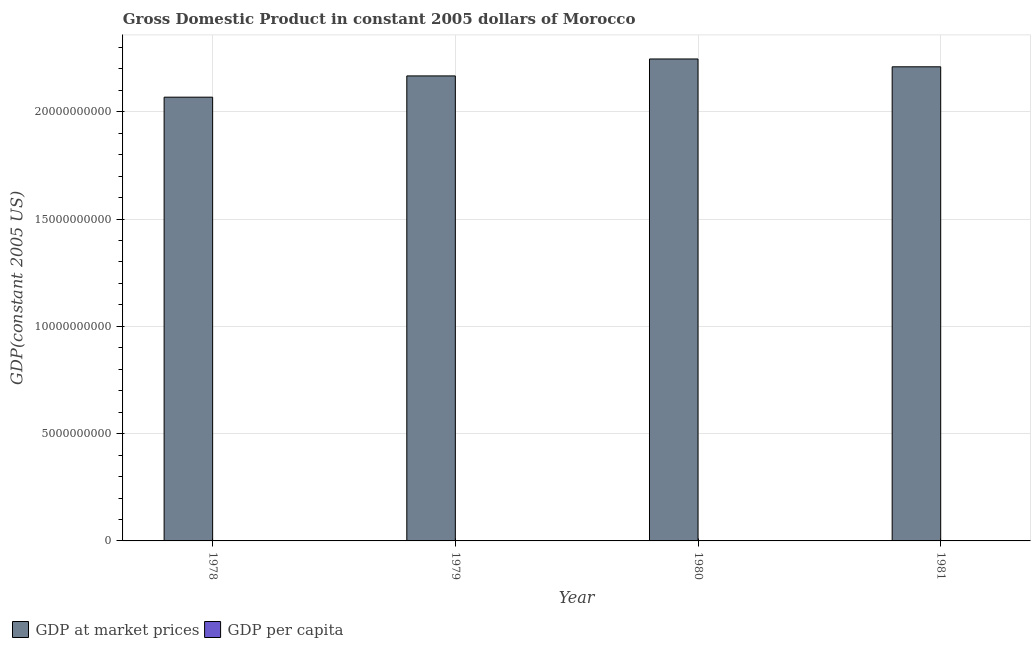How many different coloured bars are there?
Your answer should be compact. 2. What is the label of the 4th group of bars from the left?
Provide a succinct answer. 1981. What is the gdp at market prices in 1978?
Give a very brief answer. 2.07e+1. Across all years, what is the maximum gdp at market prices?
Offer a very short reply. 2.25e+1. Across all years, what is the minimum gdp at market prices?
Provide a succinct answer. 2.07e+1. In which year was the gdp at market prices minimum?
Give a very brief answer. 1978. What is the total gdp per capita in the graph?
Your response must be concise. 4349.45. What is the difference between the gdp per capita in 1978 and that in 1979?
Your response must be concise. -24.17. What is the difference between the gdp per capita in 1979 and the gdp at market prices in 1980?
Your answer should be very brief. -12.37. What is the average gdp at market prices per year?
Your answer should be very brief. 2.17e+1. In how many years, is the gdp per capita greater than 1000000000 US$?
Provide a short and direct response. 0. What is the ratio of the gdp at market prices in 1978 to that in 1980?
Your answer should be very brief. 0.92. Is the gdp at market prices in 1978 less than that in 1980?
Ensure brevity in your answer.  Yes. Is the difference between the gdp per capita in 1978 and 1980 greater than the difference between the gdp at market prices in 1978 and 1980?
Provide a short and direct response. No. What is the difference between the highest and the second highest gdp at market prices?
Give a very brief answer. 3.65e+08. What is the difference between the highest and the lowest gdp per capita?
Make the answer very short. 44.57. Is the sum of the gdp at market prices in 1979 and 1981 greater than the maximum gdp per capita across all years?
Offer a very short reply. Yes. What does the 2nd bar from the left in 1980 represents?
Keep it short and to the point. GDP per capita. What does the 1st bar from the right in 1978 represents?
Offer a very short reply. GDP per capita. Are all the bars in the graph horizontal?
Give a very brief answer. No. How many years are there in the graph?
Your answer should be very brief. 4. What is the difference between two consecutive major ticks on the Y-axis?
Provide a succinct answer. 5.00e+09. Does the graph contain grids?
Offer a very short reply. Yes. Where does the legend appear in the graph?
Give a very brief answer. Bottom left. How many legend labels are there?
Keep it short and to the point. 2. What is the title of the graph?
Offer a terse response. Gross Domestic Product in constant 2005 dollars of Morocco. What is the label or title of the Y-axis?
Provide a succinct answer. GDP(constant 2005 US). What is the GDP(constant 2005 US) in GDP at market prices in 1978?
Offer a very short reply. 2.07e+1. What is the GDP(constant 2005 US) in GDP per capita in 1978?
Give a very brief answer. 1074.2. What is the GDP(constant 2005 US) in GDP at market prices in 1979?
Provide a succinct answer. 2.17e+1. What is the GDP(constant 2005 US) in GDP per capita in 1979?
Give a very brief answer. 1098.36. What is the GDP(constant 2005 US) of GDP at market prices in 1980?
Give a very brief answer. 2.25e+1. What is the GDP(constant 2005 US) in GDP per capita in 1980?
Make the answer very short. 1110.73. What is the GDP(constant 2005 US) in GDP at market prices in 1981?
Provide a succinct answer. 2.21e+1. What is the GDP(constant 2005 US) of GDP per capita in 1981?
Provide a short and direct response. 1066.16. Across all years, what is the maximum GDP(constant 2005 US) in GDP at market prices?
Offer a terse response. 2.25e+1. Across all years, what is the maximum GDP(constant 2005 US) in GDP per capita?
Your response must be concise. 1110.73. Across all years, what is the minimum GDP(constant 2005 US) of GDP at market prices?
Provide a succinct answer. 2.07e+1. Across all years, what is the minimum GDP(constant 2005 US) of GDP per capita?
Keep it short and to the point. 1066.16. What is the total GDP(constant 2005 US) of GDP at market prices in the graph?
Your answer should be compact. 8.69e+1. What is the total GDP(constant 2005 US) in GDP per capita in the graph?
Keep it short and to the point. 4349.45. What is the difference between the GDP(constant 2005 US) in GDP at market prices in 1978 and that in 1979?
Your response must be concise. -9.91e+08. What is the difference between the GDP(constant 2005 US) of GDP per capita in 1978 and that in 1979?
Give a very brief answer. -24.17. What is the difference between the GDP(constant 2005 US) of GDP at market prices in 1978 and that in 1980?
Your answer should be compact. -1.78e+09. What is the difference between the GDP(constant 2005 US) in GDP per capita in 1978 and that in 1980?
Make the answer very short. -36.53. What is the difference between the GDP(constant 2005 US) in GDP at market prices in 1978 and that in 1981?
Provide a succinct answer. -1.42e+09. What is the difference between the GDP(constant 2005 US) of GDP per capita in 1978 and that in 1981?
Provide a short and direct response. 8.03. What is the difference between the GDP(constant 2005 US) in GDP at market prices in 1979 and that in 1980?
Your answer should be very brief. -7.89e+08. What is the difference between the GDP(constant 2005 US) of GDP per capita in 1979 and that in 1980?
Ensure brevity in your answer.  -12.37. What is the difference between the GDP(constant 2005 US) of GDP at market prices in 1979 and that in 1981?
Your answer should be very brief. -4.24e+08. What is the difference between the GDP(constant 2005 US) in GDP per capita in 1979 and that in 1981?
Keep it short and to the point. 32.2. What is the difference between the GDP(constant 2005 US) in GDP at market prices in 1980 and that in 1981?
Your answer should be compact. 3.65e+08. What is the difference between the GDP(constant 2005 US) of GDP per capita in 1980 and that in 1981?
Your answer should be very brief. 44.57. What is the difference between the GDP(constant 2005 US) in GDP at market prices in 1978 and the GDP(constant 2005 US) in GDP per capita in 1979?
Ensure brevity in your answer.  2.07e+1. What is the difference between the GDP(constant 2005 US) in GDP at market prices in 1978 and the GDP(constant 2005 US) in GDP per capita in 1980?
Offer a terse response. 2.07e+1. What is the difference between the GDP(constant 2005 US) in GDP at market prices in 1978 and the GDP(constant 2005 US) in GDP per capita in 1981?
Ensure brevity in your answer.  2.07e+1. What is the difference between the GDP(constant 2005 US) in GDP at market prices in 1979 and the GDP(constant 2005 US) in GDP per capita in 1980?
Ensure brevity in your answer.  2.17e+1. What is the difference between the GDP(constant 2005 US) of GDP at market prices in 1979 and the GDP(constant 2005 US) of GDP per capita in 1981?
Offer a terse response. 2.17e+1. What is the difference between the GDP(constant 2005 US) in GDP at market prices in 1980 and the GDP(constant 2005 US) in GDP per capita in 1981?
Your response must be concise. 2.25e+1. What is the average GDP(constant 2005 US) of GDP at market prices per year?
Your answer should be compact. 2.17e+1. What is the average GDP(constant 2005 US) in GDP per capita per year?
Ensure brevity in your answer.  1087.36. In the year 1978, what is the difference between the GDP(constant 2005 US) in GDP at market prices and GDP(constant 2005 US) in GDP per capita?
Make the answer very short. 2.07e+1. In the year 1979, what is the difference between the GDP(constant 2005 US) of GDP at market prices and GDP(constant 2005 US) of GDP per capita?
Ensure brevity in your answer.  2.17e+1. In the year 1980, what is the difference between the GDP(constant 2005 US) in GDP at market prices and GDP(constant 2005 US) in GDP per capita?
Keep it short and to the point. 2.25e+1. In the year 1981, what is the difference between the GDP(constant 2005 US) in GDP at market prices and GDP(constant 2005 US) in GDP per capita?
Your answer should be very brief. 2.21e+1. What is the ratio of the GDP(constant 2005 US) of GDP at market prices in 1978 to that in 1979?
Your answer should be compact. 0.95. What is the ratio of the GDP(constant 2005 US) of GDP per capita in 1978 to that in 1979?
Provide a succinct answer. 0.98. What is the ratio of the GDP(constant 2005 US) of GDP at market prices in 1978 to that in 1980?
Offer a very short reply. 0.92. What is the ratio of the GDP(constant 2005 US) of GDP per capita in 1978 to that in 1980?
Ensure brevity in your answer.  0.97. What is the ratio of the GDP(constant 2005 US) in GDP at market prices in 1978 to that in 1981?
Give a very brief answer. 0.94. What is the ratio of the GDP(constant 2005 US) of GDP per capita in 1978 to that in 1981?
Your response must be concise. 1.01. What is the ratio of the GDP(constant 2005 US) of GDP at market prices in 1979 to that in 1980?
Ensure brevity in your answer.  0.96. What is the ratio of the GDP(constant 2005 US) of GDP per capita in 1979 to that in 1980?
Your response must be concise. 0.99. What is the ratio of the GDP(constant 2005 US) of GDP at market prices in 1979 to that in 1981?
Offer a very short reply. 0.98. What is the ratio of the GDP(constant 2005 US) in GDP per capita in 1979 to that in 1981?
Your answer should be very brief. 1.03. What is the ratio of the GDP(constant 2005 US) of GDP at market prices in 1980 to that in 1981?
Offer a terse response. 1.02. What is the ratio of the GDP(constant 2005 US) of GDP per capita in 1980 to that in 1981?
Ensure brevity in your answer.  1.04. What is the difference between the highest and the second highest GDP(constant 2005 US) of GDP at market prices?
Keep it short and to the point. 3.65e+08. What is the difference between the highest and the second highest GDP(constant 2005 US) of GDP per capita?
Give a very brief answer. 12.37. What is the difference between the highest and the lowest GDP(constant 2005 US) of GDP at market prices?
Offer a terse response. 1.78e+09. What is the difference between the highest and the lowest GDP(constant 2005 US) in GDP per capita?
Your answer should be compact. 44.57. 